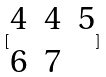Convert formula to latex. <formula><loc_0><loc_0><loc_500><loc_500>[ \begin{matrix} 4 & 4 & 5 \\ 6 & 7 \end{matrix} ]</formula> 